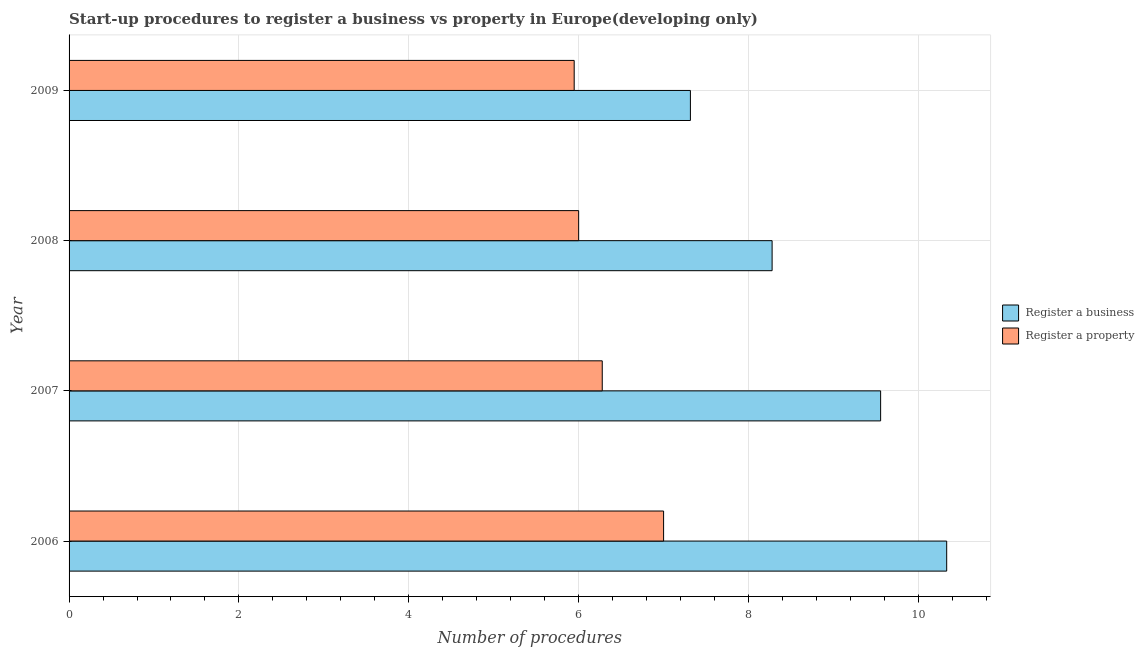How many groups of bars are there?
Your answer should be very brief. 4. How many bars are there on the 2nd tick from the bottom?
Keep it short and to the point. 2. What is the label of the 4th group of bars from the top?
Your answer should be compact. 2006. In how many cases, is the number of bars for a given year not equal to the number of legend labels?
Give a very brief answer. 0. What is the number of procedures to register a property in 2006?
Your answer should be compact. 7. Across all years, what is the maximum number of procedures to register a business?
Give a very brief answer. 10.33. Across all years, what is the minimum number of procedures to register a business?
Ensure brevity in your answer.  7.32. In which year was the number of procedures to register a business maximum?
Your answer should be compact. 2006. In which year was the number of procedures to register a business minimum?
Provide a succinct answer. 2009. What is the total number of procedures to register a business in the graph?
Make the answer very short. 35.48. What is the difference between the number of procedures to register a business in 2007 and that in 2009?
Provide a short and direct response. 2.24. What is the difference between the number of procedures to register a business in 2007 and the number of procedures to register a property in 2006?
Offer a terse response. 2.56. What is the average number of procedures to register a business per year?
Your answer should be compact. 8.87. In the year 2007, what is the difference between the number of procedures to register a business and number of procedures to register a property?
Ensure brevity in your answer.  3.28. What is the ratio of the number of procedures to register a business in 2007 to that in 2008?
Keep it short and to the point. 1.15. Is the difference between the number of procedures to register a business in 2008 and 2009 greater than the difference between the number of procedures to register a property in 2008 and 2009?
Provide a short and direct response. Yes. What is the difference between the highest and the second highest number of procedures to register a business?
Provide a succinct answer. 0.78. What is the difference between the highest and the lowest number of procedures to register a business?
Your answer should be very brief. 3.02. Is the sum of the number of procedures to register a business in 2007 and 2008 greater than the maximum number of procedures to register a property across all years?
Your response must be concise. Yes. What does the 1st bar from the top in 2007 represents?
Your answer should be compact. Register a property. What does the 2nd bar from the bottom in 2009 represents?
Provide a succinct answer. Register a property. How many years are there in the graph?
Give a very brief answer. 4. What is the difference between two consecutive major ticks on the X-axis?
Provide a succinct answer. 2. Are the values on the major ticks of X-axis written in scientific E-notation?
Provide a short and direct response. No. Where does the legend appear in the graph?
Your response must be concise. Center right. What is the title of the graph?
Provide a succinct answer. Start-up procedures to register a business vs property in Europe(developing only). What is the label or title of the X-axis?
Ensure brevity in your answer.  Number of procedures. What is the label or title of the Y-axis?
Provide a short and direct response. Year. What is the Number of procedures of Register a business in 2006?
Give a very brief answer. 10.33. What is the Number of procedures of Register a business in 2007?
Offer a very short reply. 9.56. What is the Number of procedures of Register a property in 2007?
Ensure brevity in your answer.  6.28. What is the Number of procedures of Register a business in 2008?
Provide a short and direct response. 8.28. What is the Number of procedures of Register a business in 2009?
Offer a terse response. 7.32. What is the Number of procedures of Register a property in 2009?
Your response must be concise. 5.95. Across all years, what is the maximum Number of procedures of Register a business?
Your answer should be very brief. 10.33. Across all years, what is the maximum Number of procedures of Register a property?
Offer a terse response. 7. Across all years, what is the minimum Number of procedures in Register a business?
Provide a short and direct response. 7.32. Across all years, what is the minimum Number of procedures of Register a property?
Make the answer very short. 5.95. What is the total Number of procedures of Register a business in the graph?
Your response must be concise. 35.48. What is the total Number of procedures of Register a property in the graph?
Your response must be concise. 25.23. What is the difference between the Number of procedures in Register a business in 2006 and that in 2007?
Ensure brevity in your answer.  0.78. What is the difference between the Number of procedures of Register a property in 2006 and that in 2007?
Provide a short and direct response. 0.72. What is the difference between the Number of procedures in Register a business in 2006 and that in 2008?
Make the answer very short. 2.06. What is the difference between the Number of procedures in Register a business in 2006 and that in 2009?
Your answer should be compact. 3.02. What is the difference between the Number of procedures in Register a property in 2006 and that in 2009?
Your response must be concise. 1.05. What is the difference between the Number of procedures of Register a business in 2007 and that in 2008?
Ensure brevity in your answer.  1.28. What is the difference between the Number of procedures in Register a property in 2007 and that in 2008?
Give a very brief answer. 0.28. What is the difference between the Number of procedures in Register a business in 2007 and that in 2009?
Make the answer very short. 2.24. What is the difference between the Number of procedures of Register a property in 2007 and that in 2009?
Your answer should be compact. 0.33. What is the difference between the Number of procedures in Register a property in 2008 and that in 2009?
Provide a short and direct response. 0.05. What is the difference between the Number of procedures in Register a business in 2006 and the Number of procedures in Register a property in 2007?
Ensure brevity in your answer.  4.06. What is the difference between the Number of procedures in Register a business in 2006 and the Number of procedures in Register a property in 2008?
Provide a short and direct response. 4.33. What is the difference between the Number of procedures of Register a business in 2006 and the Number of procedures of Register a property in 2009?
Your answer should be very brief. 4.39. What is the difference between the Number of procedures in Register a business in 2007 and the Number of procedures in Register a property in 2008?
Offer a very short reply. 3.56. What is the difference between the Number of procedures of Register a business in 2007 and the Number of procedures of Register a property in 2009?
Keep it short and to the point. 3.61. What is the difference between the Number of procedures in Register a business in 2008 and the Number of procedures in Register a property in 2009?
Provide a succinct answer. 2.33. What is the average Number of procedures of Register a business per year?
Your response must be concise. 8.87. What is the average Number of procedures in Register a property per year?
Make the answer very short. 6.31. In the year 2006, what is the difference between the Number of procedures in Register a business and Number of procedures in Register a property?
Ensure brevity in your answer.  3.33. In the year 2007, what is the difference between the Number of procedures of Register a business and Number of procedures of Register a property?
Provide a short and direct response. 3.28. In the year 2008, what is the difference between the Number of procedures in Register a business and Number of procedures in Register a property?
Offer a very short reply. 2.28. In the year 2009, what is the difference between the Number of procedures of Register a business and Number of procedures of Register a property?
Give a very brief answer. 1.37. What is the ratio of the Number of procedures of Register a business in 2006 to that in 2007?
Make the answer very short. 1.08. What is the ratio of the Number of procedures in Register a property in 2006 to that in 2007?
Keep it short and to the point. 1.11. What is the ratio of the Number of procedures in Register a business in 2006 to that in 2008?
Ensure brevity in your answer.  1.25. What is the ratio of the Number of procedures in Register a property in 2006 to that in 2008?
Provide a short and direct response. 1.17. What is the ratio of the Number of procedures in Register a business in 2006 to that in 2009?
Offer a very short reply. 1.41. What is the ratio of the Number of procedures in Register a property in 2006 to that in 2009?
Make the answer very short. 1.18. What is the ratio of the Number of procedures in Register a business in 2007 to that in 2008?
Keep it short and to the point. 1.15. What is the ratio of the Number of procedures of Register a property in 2007 to that in 2008?
Make the answer very short. 1.05. What is the ratio of the Number of procedures of Register a business in 2007 to that in 2009?
Make the answer very short. 1.31. What is the ratio of the Number of procedures in Register a property in 2007 to that in 2009?
Your response must be concise. 1.06. What is the ratio of the Number of procedures in Register a business in 2008 to that in 2009?
Give a very brief answer. 1.13. What is the ratio of the Number of procedures of Register a property in 2008 to that in 2009?
Your answer should be compact. 1.01. What is the difference between the highest and the second highest Number of procedures in Register a business?
Your answer should be compact. 0.78. What is the difference between the highest and the second highest Number of procedures of Register a property?
Provide a short and direct response. 0.72. What is the difference between the highest and the lowest Number of procedures of Register a business?
Keep it short and to the point. 3.02. What is the difference between the highest and the lowest Number of procedures in Register a property?
Your response must be concise. 1.05. 